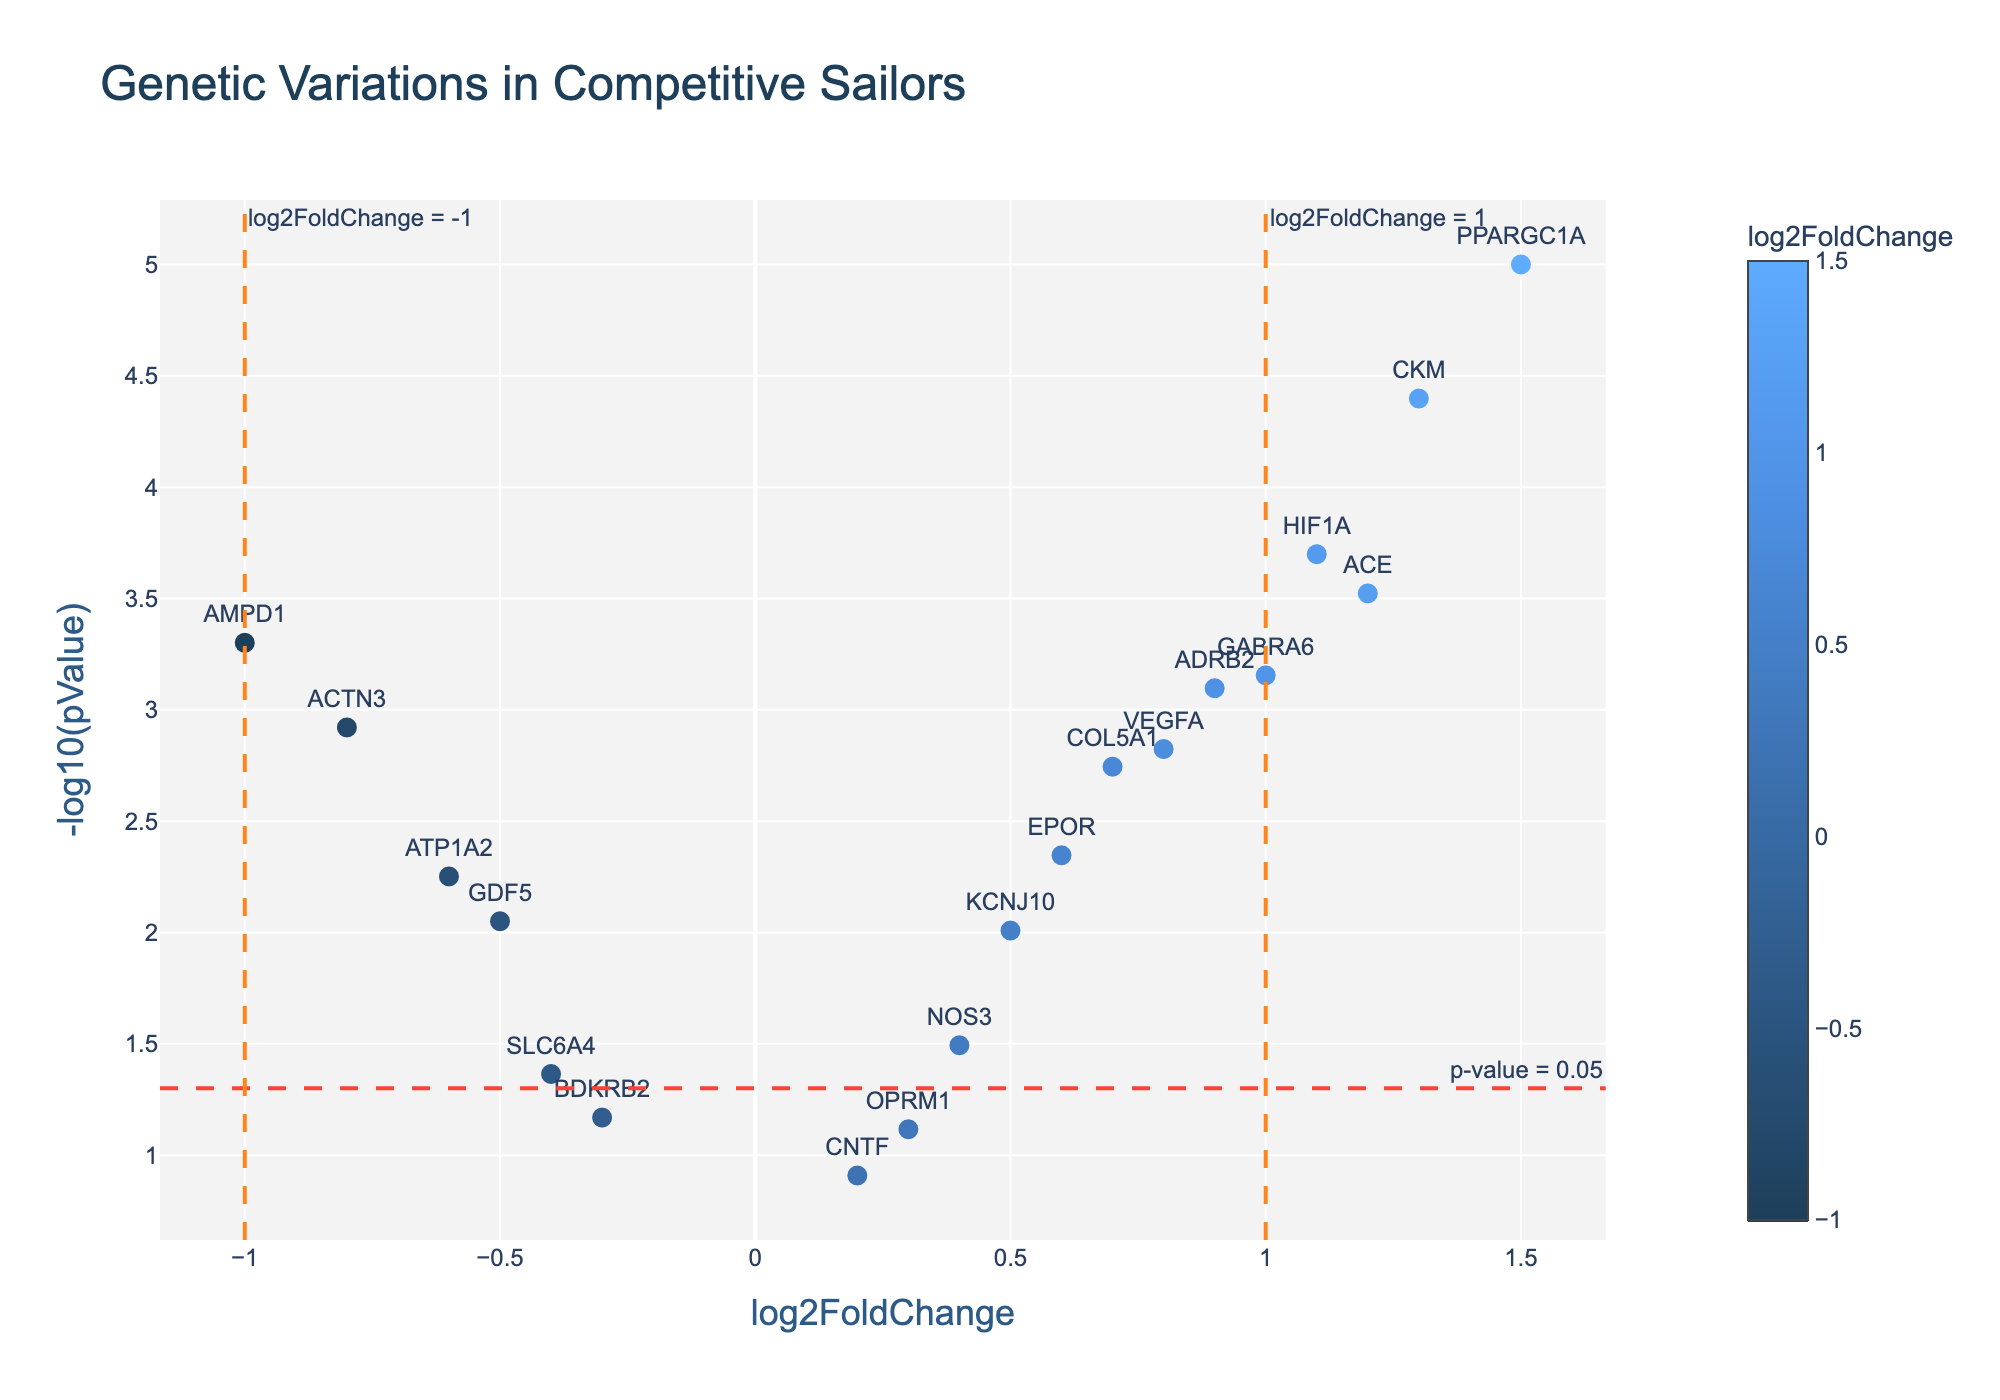What is the title of the figure? The title is typically displayed at the top center of the chart.
Answer: Genetic Variations in Competitive Sailors What is the significance threshold for the p-value represented by the horizontal dashed line? The threshold for significance in p-values is represented where the horizontal dashed line intersects the y-axis. This value is derived from \(-\log_{10}(0.05)\).
Answer: 1.3 How many genes have a p-value lower than 0.05? To find this, count the data points that are above the horizontal dashed line indicating the significance threshold of \(-\log_{10}(0.05) = 1.3\).
Answer: 15 Which gene has the highest log2FoldChange that is statistically significant? Identify the data point above the significance threshold (p-value < 0.05) with the highest value on the x-axis.
Answer: PPARGC1A What are the two genes with the lowest log2FoldChange values that are statistically significant? Identify the two data points above the significance threshold (p-value < 0.05) that have the smallest values on the x-axis.
Answer: AMPD1 and ACTN3 How does the position of the gene ADRB2 compare to HIF1A in terms of log2FoldChange and p-value? Compare the x-axis (log2FoldChange) and y-axis (\(-\log_{10}(p-value)\)) positions of ADRB2 and HIF1A.
Answer: ADRB2 has a higher log2FoldChange but a lower statistical significance compared to HIF1A How many genes show a log2FoldChange greater than 1 and are statistically significant? Count the data points above the significance threshold (p-value < 0.05) that also have a log2FoldChange value greater than 1.
Answer: 3 Are there any genes with a statistically significant negative log2FoldChange? If so, which one(s)? Identify any data points above the significance threshold with a negative log2FoldChange.
Answer: ACTN3, AMPD1, and ATP1A2 Which gene shows the highest statistical significance? Identify the data point with the highest \(-\log_{10}(p-value)\) value on the y-axis.
Answer: PPARGC1A What is the log2FoldChange and p-value of the gene VEGFA? Extract the values by examining the position of the associated marker and its hovertext.
Answer: log2FoldChange: 0.8, p-value: 0.0015 